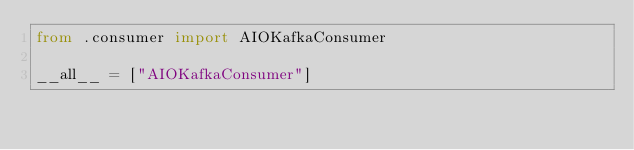Convert code to text. <code><loc_0><loc_0><loc_500><loc_500><_Python_>from .consumer import AIOKafkaConsumer

__all__ = ["AIOKafkaConsumer"]
</code> 